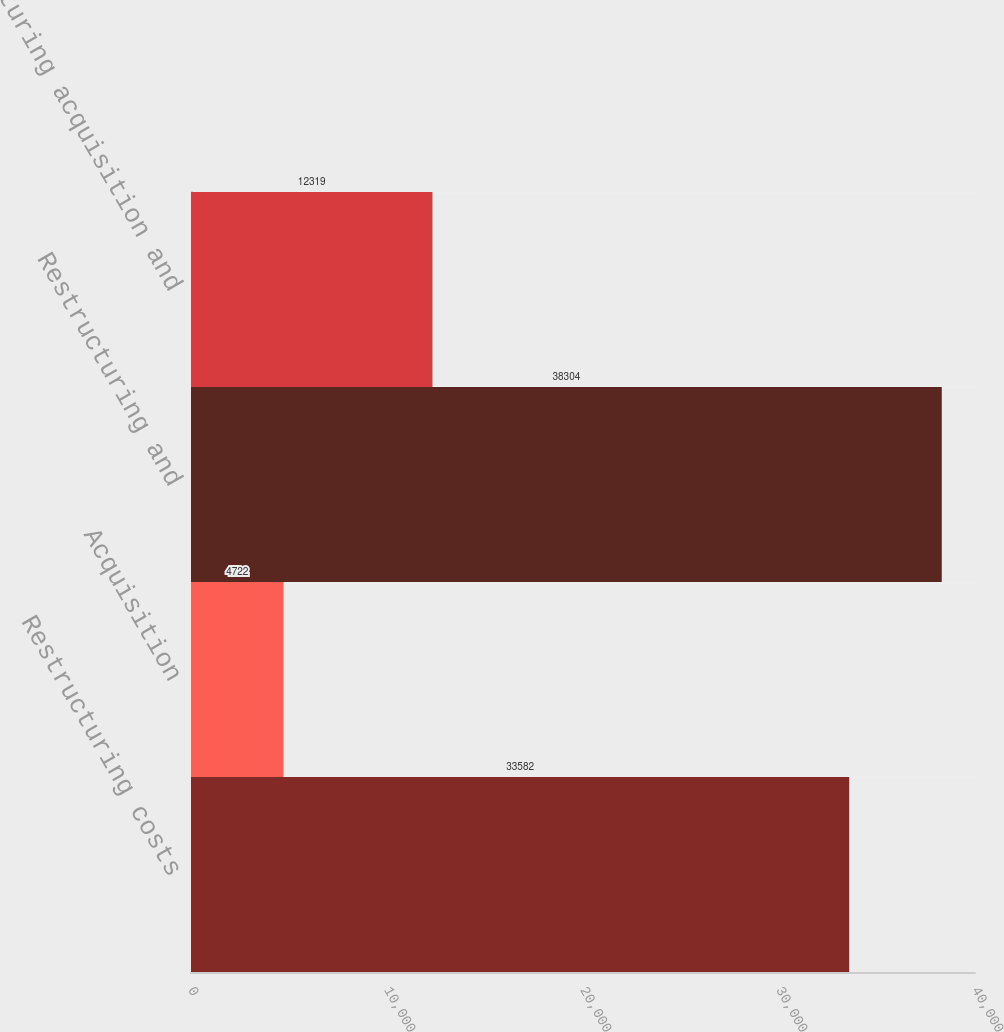<chart> <loc_0><loc_0><loc_500><loc_500><bar_chart><fcel>Restructuring costs<fcel>Acquisition<fcel>Restructuring and<fcel>Restructuring acquisition and<nl><fcel>33582<fcel>4722<fcel>38304<fcel>12319<nl></chart> 